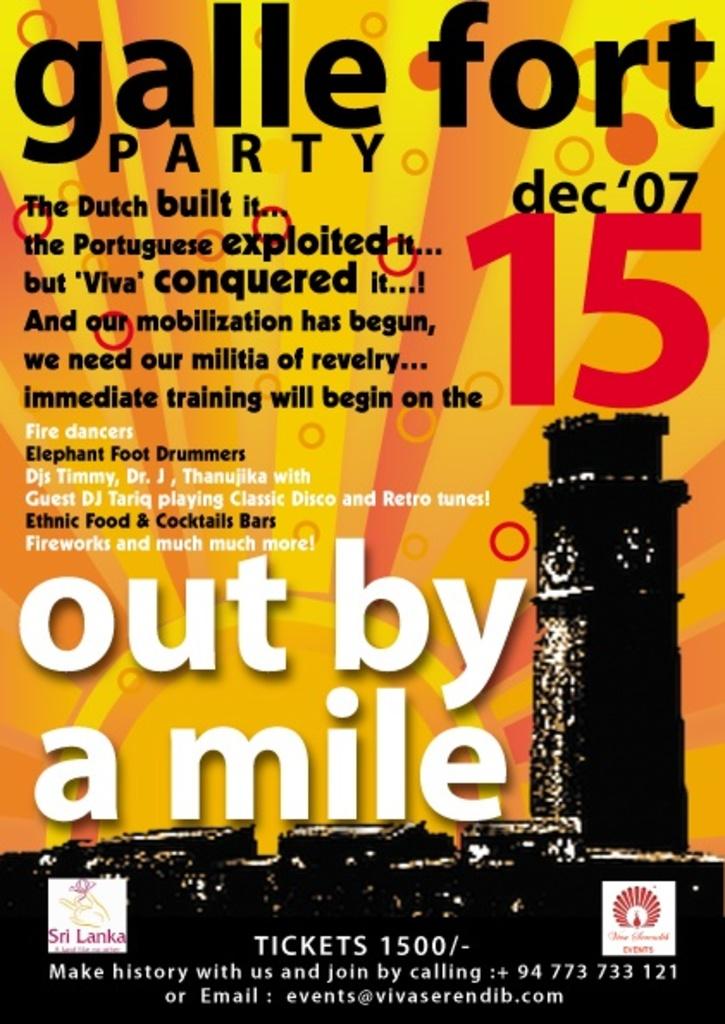Where would you spend an email about tickets?
Make the answer very short. Events@vivaserendib.com. What is the date on the flyer?
Your answer should be compact. Dec 15 '07. 